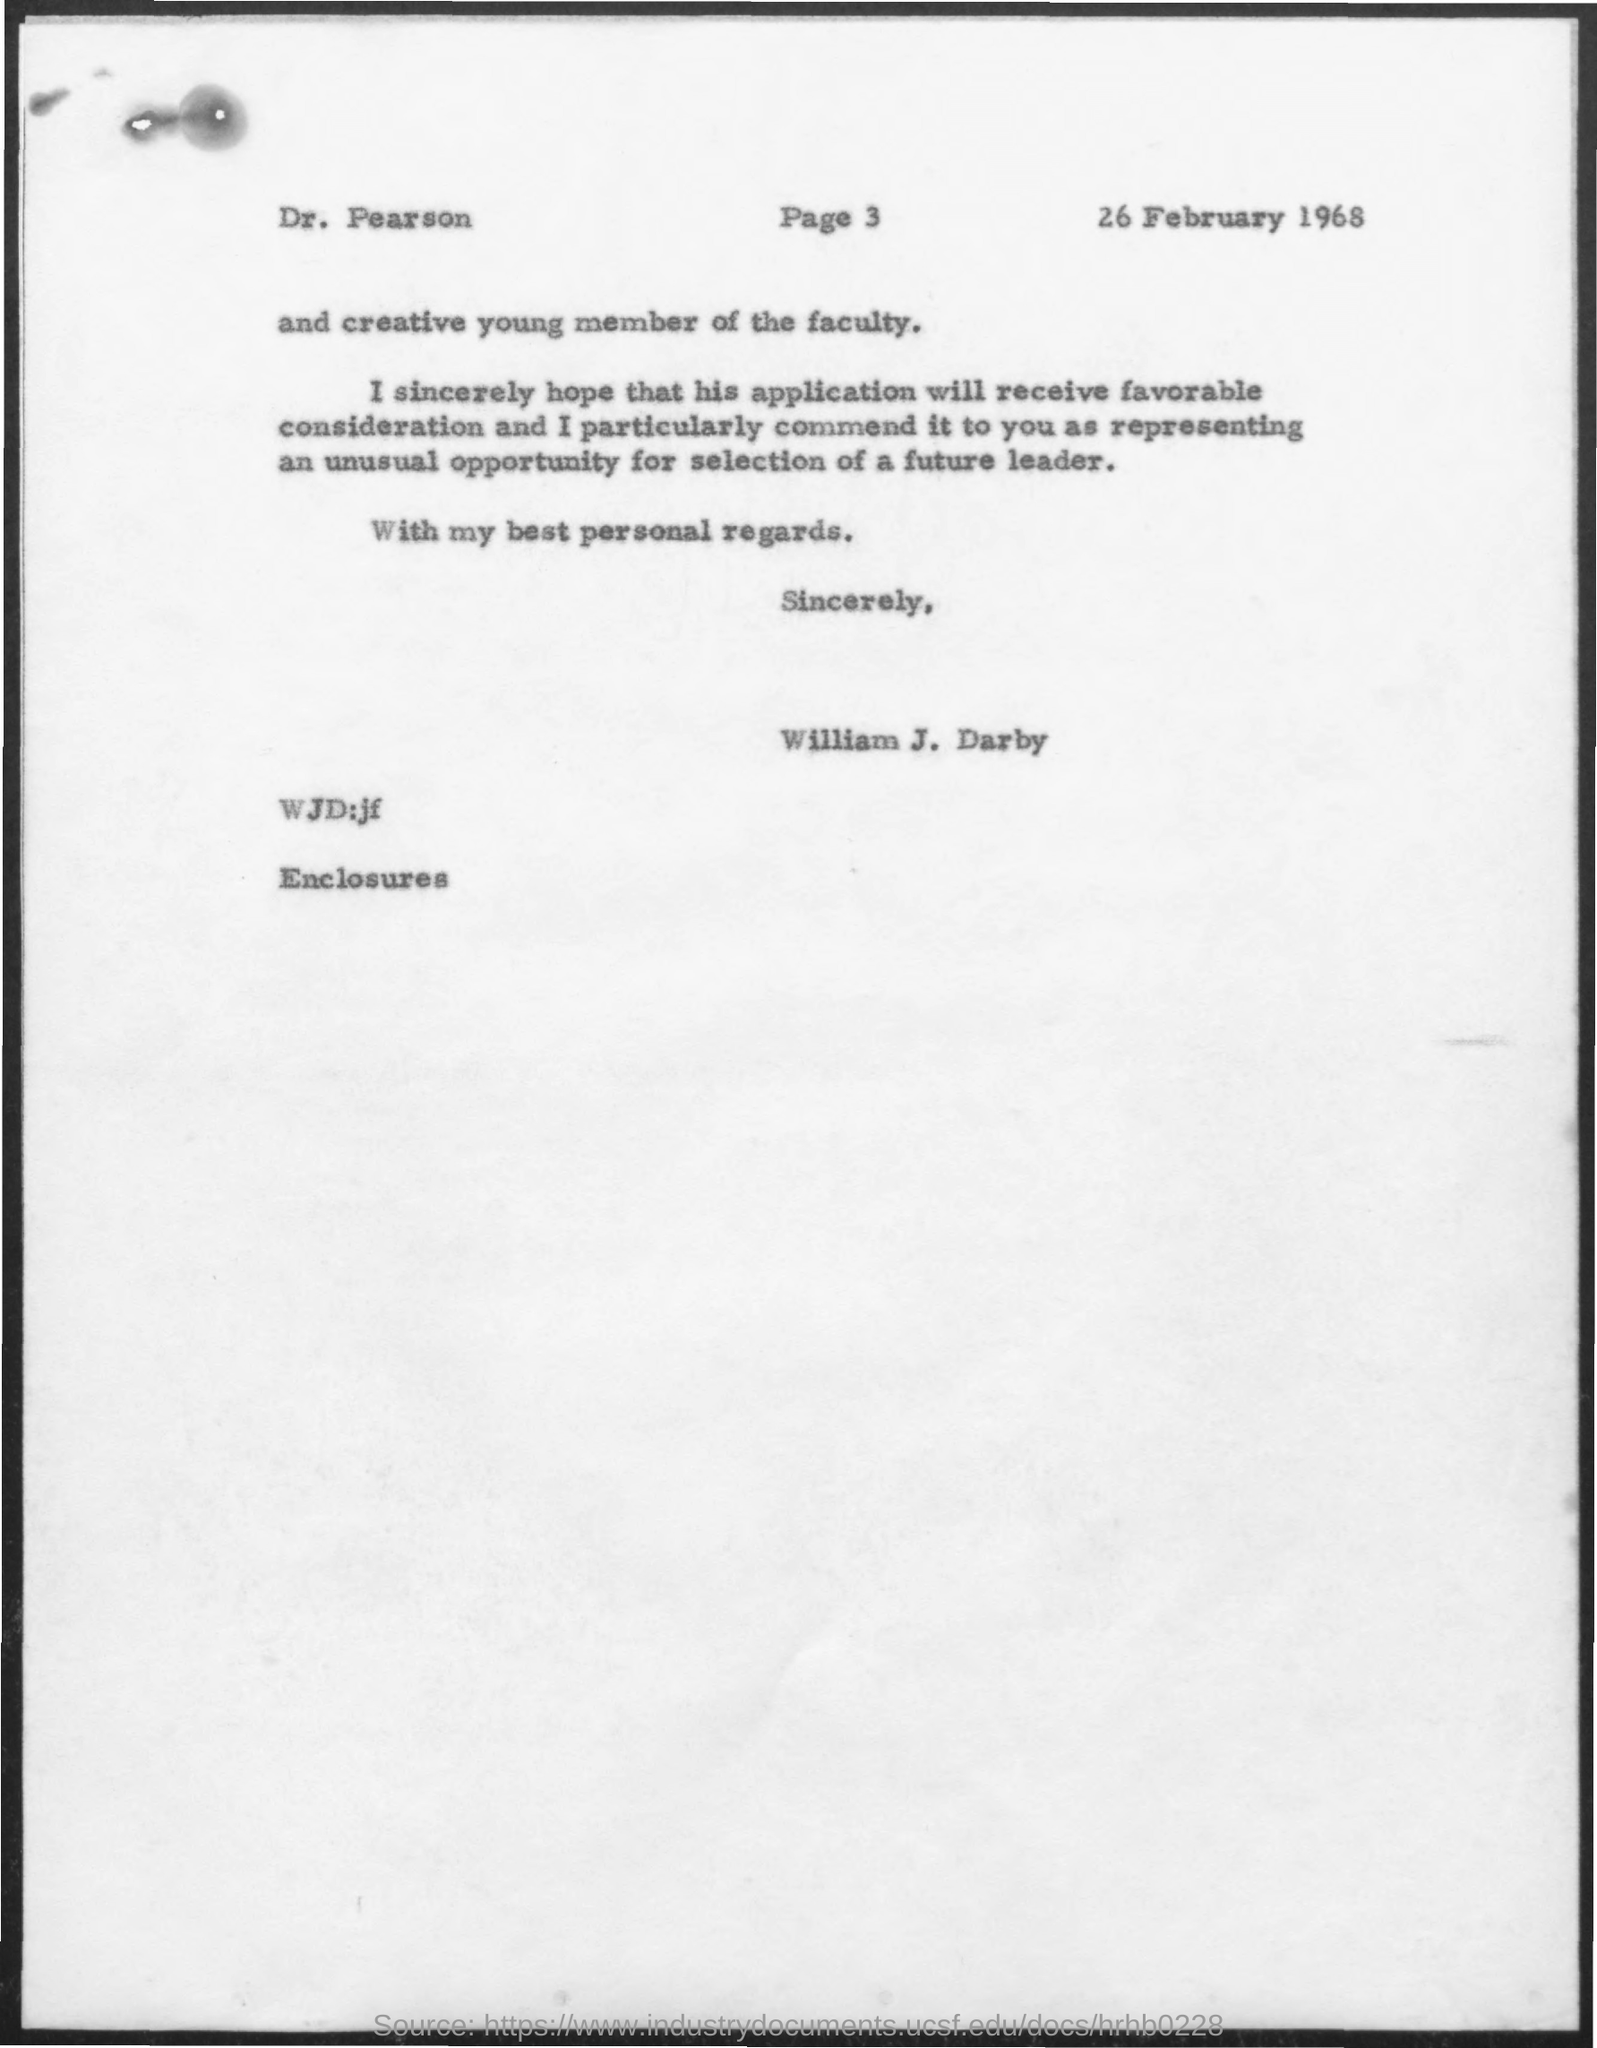What is the date mentioned in the given page ?
Offer a terse response. 26 february 1968. 